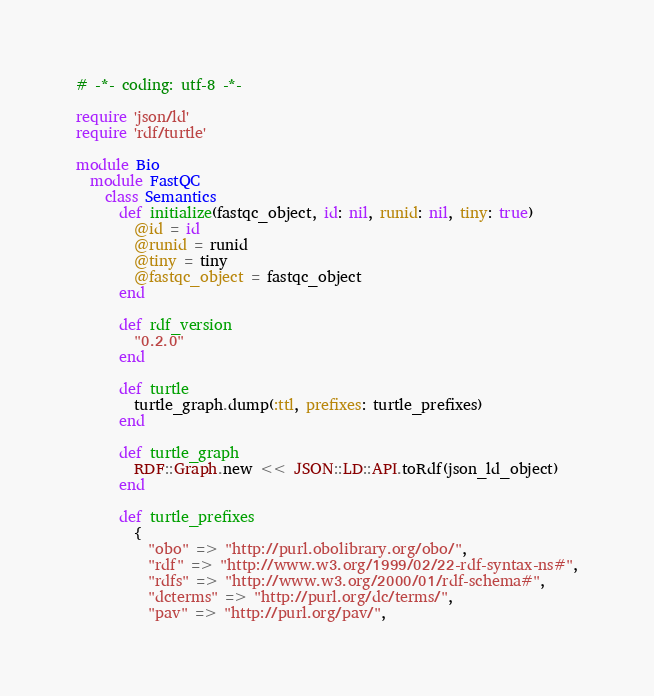<code> <loc_0><loc_0><loc_500><loc_500><_Ruby_># -*- coding: utf-8 -*-

require 'json/ld'
require 'rdf/turtle'

module Bio
  module FastQC
    class Semantics
      def initialize(fastqc_object, id: nil, runid: nil, tiny: true)
        @id = id
        @runid = runid
        @tiny = tiny
        @fastqc_object = fastqc_object
      end

      def rdf_version
        "0.2.0"
      end

      def turtle
        turtle_graph.dump(:ttl, prefixes: turtle_prefixes)
      end

      def turtle_graph
        RDF::Graph.new << JSON::LD::API.toRdf(json_ld_object)
      end

      def turtle_prefixes
        {
          "obo" => "http://purl.obolibrary.org/obo/",
          "rdf" => "http://www.w3.org/1999/02/22-rdf-syntax-ns#",
          "rdfs" => "http://www.w3.org/2000/01/rdf-schema#",
          "dcterms" => "http://purl.org/dc/terms/",
          "pav" => "http://purl.org/pav/",</code> 